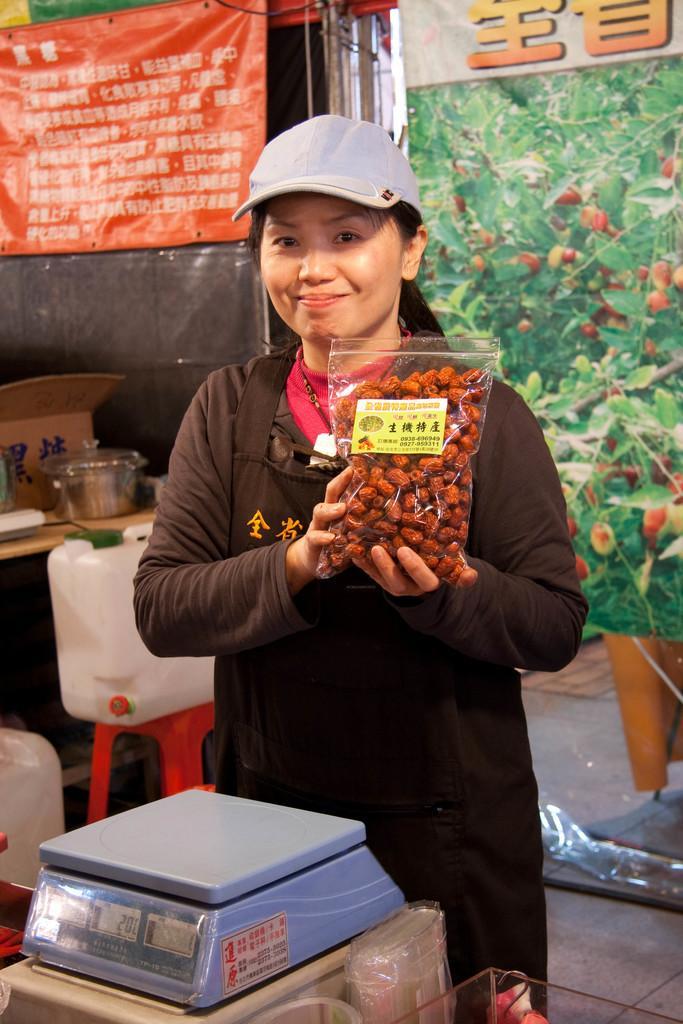How would you summarize this image in a sentence or two? In this image we can see a woman standing and holding a packet, in front of her we can see a weight balance, there are water cans, stool and a table, on the table, we can see a bowl, cardboard box and some other objects, in the background, we can see the banners with some text, fruits and plants. 